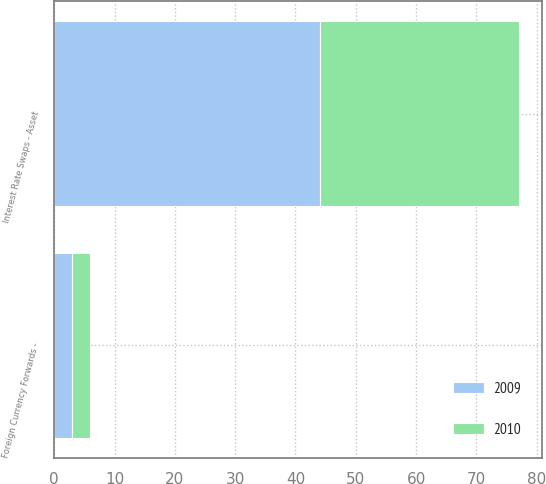Convert chart. <chart><loc_0><loc_0><loc_500><loc_500><stacked_bar_chart><ecel><fcel>Interest Rate Swaps - Asset<fcel>Foreign Currency Forwards -<nl><fcel>2010<fcel>33<fcel>3<nl><fcel>2009<fcel>44<fcel>3<nl></chart> 